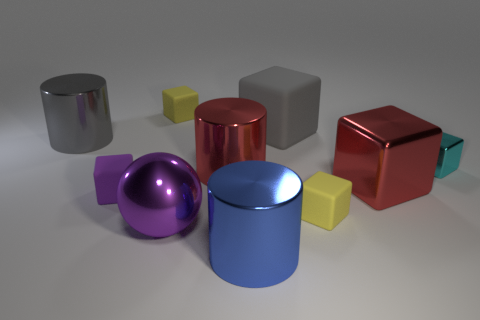Subtract all gray rubber blocks. How many blocks are left? 5 Subtract all gray blocks. How many blocks are left? 5 Subtract all blocks. How many objects are left? 4 Subtract 2 cubes. How many cubes are left? 4 Subtract 1 purple cubes. How many objects are left? 9 Subtract all gray cylinders. Subtract all cyan spheres. How many cylinders are left? 2 Subtract all cyan balls. How many gray blocks are left? 1 Subtract all big purple balls. Subtract all blue shiny objects. How many objects are left? 8 Add 5 big red metallic things. How many big red metallic things are left? 7 Add 2 tiny metallic blocks. How many tiny metallic blocks exist? 3 